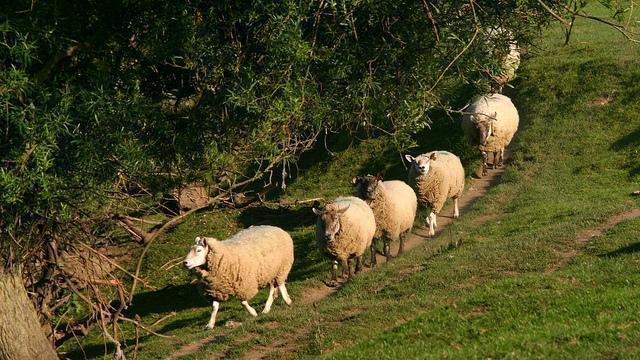What are the animals walking along?
Choose the correct response, then elucidate: 'Answer: answer
Rationale: rationale.'
Options: Trail, sidewalk, fence, rubble. Answer: trail.
Rationale: There is a worn path from walking 